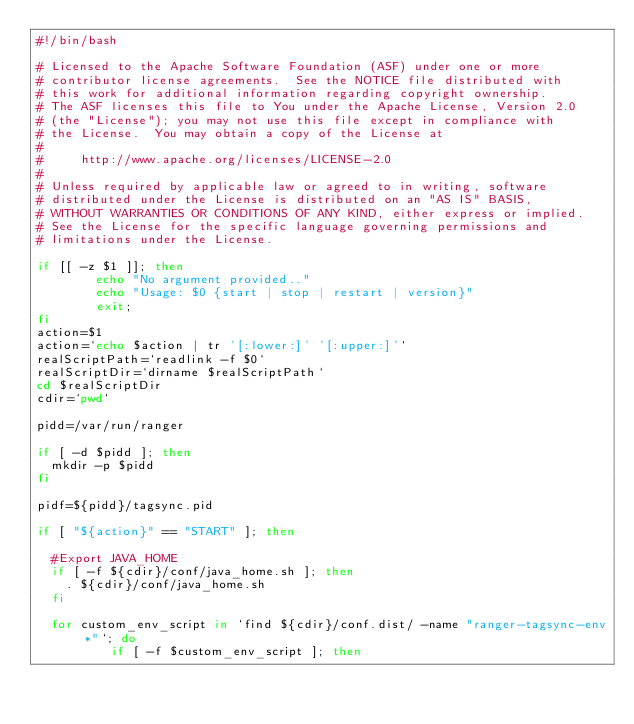<code> <loc_0><loc_0><loc_500><loc_500><_Bash_>#!/bin/bash

# Licensed to the Apache Software Foundation (ASF) under one or more
# contributor license agreements.  See the NOTICE file distributed with
# this work for additional information regarding copyright ownership.
# The ASF licenses this file to You under the Apache License, Version 2.0
# (the "License"); you may not use this file except in compliance with
# the License.  You may obtain a copy of the License at
#
#     http://www.apache.org/licenses/LICENSE-2.0
#
# Unless required by applicable law or agreed to in writing, software
# distributed under the License is distributed on an "AS IS" BASIS,
# WITHOUT WARRANTIES OR CONDITIONS OF ANY KIND, either express or implied.
# See the License for the specific language governing permissions and
# limitations under the License.

if [[ -z $1 ]]; then
        echo "No argument provided.."
        echo "Usage: $0 {start | stop | restart | version}"
        exit;
fi
action=$1
action=`echo $action | tr '[:lower:]' '[:upper:]'`
realScriptPath=`readlink -f $0`
realScriptDir=`dirname $realScriptPath`
cd $realScriptDir
cdir=`pwd`

pidd=/var/run/ranger

if [ -d $pidd ]; then
	mkdir -p $pidd
fi

pidf=${pidd}/tagsync.pid

if [ "${action}" == "START" ]; then

	#Export JAVA_HOME
	if [ -f ${cdir}/conf/java_home.sh ]; then
		. ${cdir}/conf/java_home.sh
	fi

	for custom_env_script in `find ${cdir}/conf.dist/ -name "ranger-tagsync-env*"`; do
        	if [ -f $custom_env_script ]; then</code> 